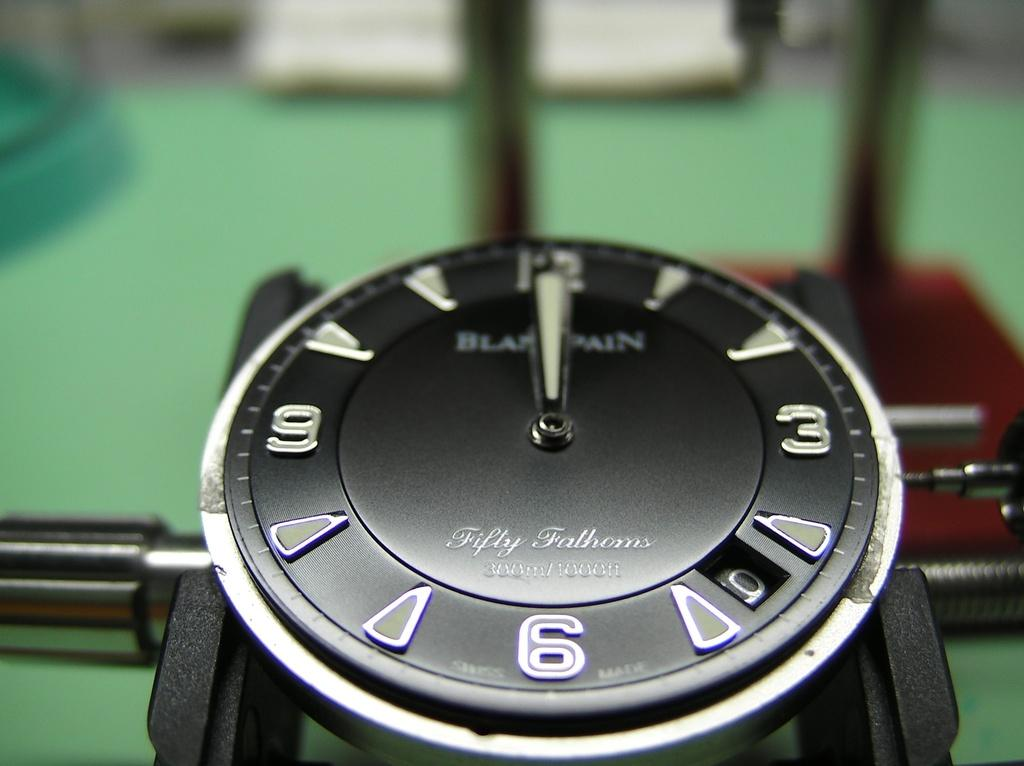<image>
Write a terse but informative summary of the picture. The black face of a wristwatch that indicates the time as 12:00. 